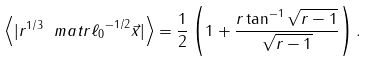Convert formula to latex. <formula><loc_0><loc_0><loc_500><loc_500>\left < | r ^ { 1 / 3 } \ m a t r { \ell _ { 0 } } ^ { - 1 / 2 } \vec { x } | \right > = \frac { 1 } { 2 } \left ( 1 + \frac { r \tan ^ { - 1 } { \sqrt { r - 1 } } } { \sqrt { r - 1 } } \right ) .</formula> 